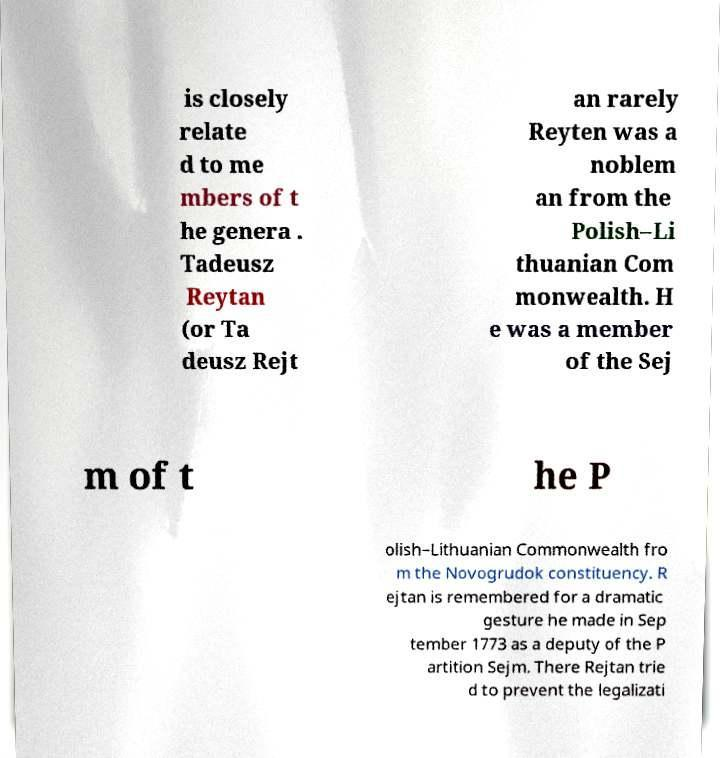Could you assist in decoding the text presented in this image and type it out clearly? is closely relate d to me mbers of t he genera . Tadeusz Reytan (or Ta deusz Rejt an rarely Reyten was a noblem an from the Polish–Li thuanian Com monwealth. H e was a member of the Sej m of t he P olish–Lithuanian Commonwealth fro m the Novogrudok constituency. R ejtan is remembered for a dramatic gesture he made in Sep tember 1773 as a deputy of the P artition Sejm. There Rejtan trie d to prevent the legalizati 